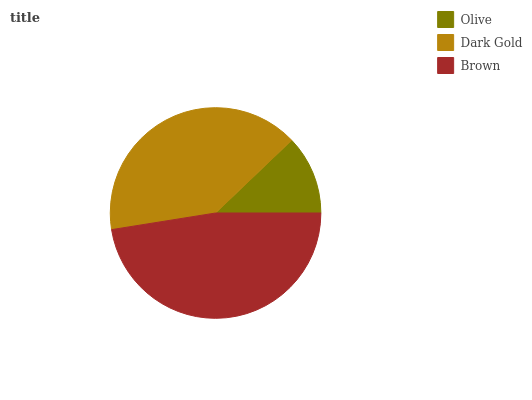Is Olive the minimum?
Answer yes or no. Yes. Is Brown the maximum?
Answer yes or no. Yes. Is Dark Gold the minimum?
Answer yes or no. No. Is Dark Gold the maximum?
Answer yes or no. No. Is Dark Gold greater than Olive?
Answer yes or no. Yes. Is Olive less than Dark Gold?
Answer yes or no. Yes. Is Olive greater than Dark Gold?
Answer yes or no. No. Is Dark Gold less than Olive?
Answer yes or no. No. Is Dark Gold the high median?
Answer yes or no. Yes. Is Dark Gold the low median?
Answer yes or no. Yes. Is Olive the high median?
Answer yes or no. No. Is Brown the low median?
Answer yes or no. No. 